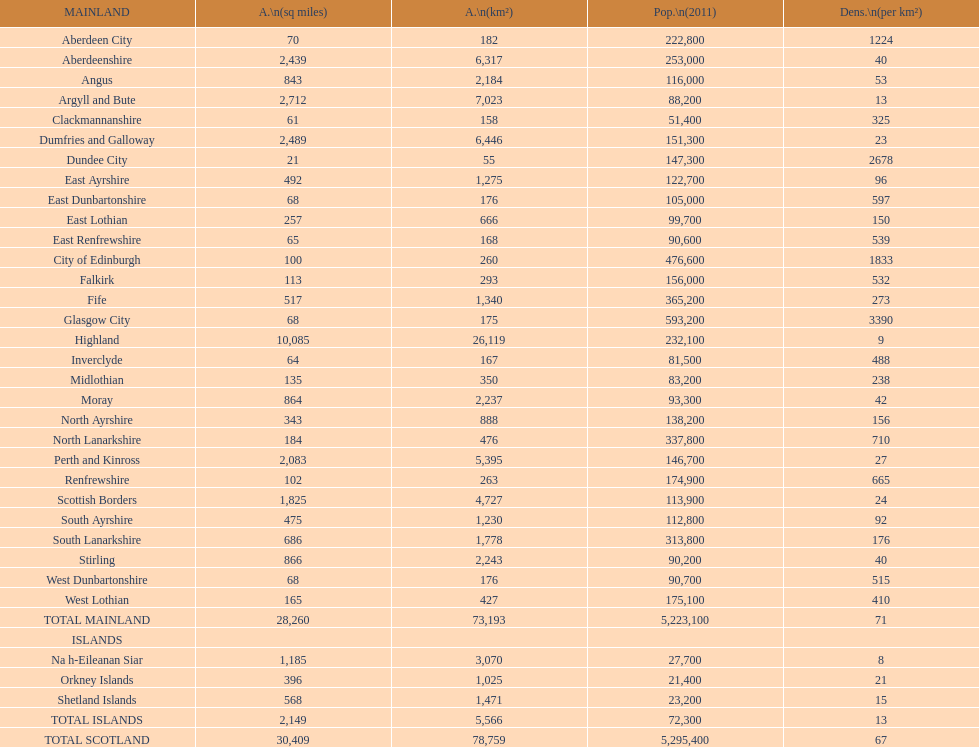What number of mainlands have populations under 100,000? 9. 